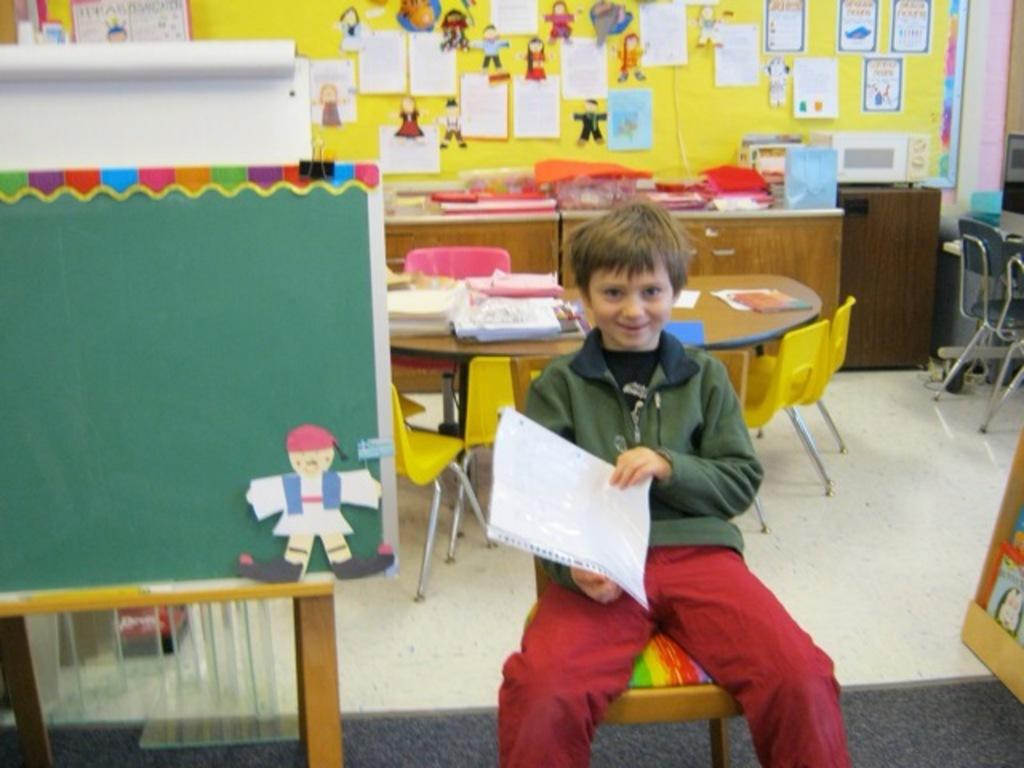Who or what is present in the image? There is a person in the image. What is the person doing in the image? The person is sitting on a chair. What type of impulse can be seen affecting the person in the image? There is no mention of an impulse or any external force affecting the person in the image. 